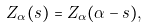Convert formula to latex. <formula><loc_0><loc_0><loc_500><loc_500>Z _ { \alpha } ( s ) = Z _ { \alpha } ( \alpha - s ) ,</formula> 